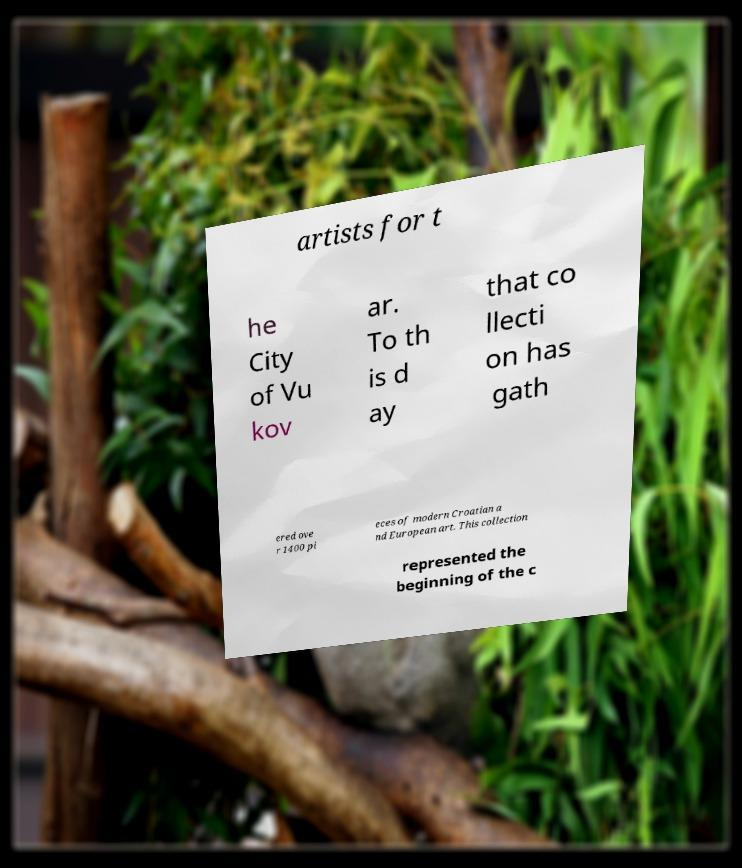Could you extract and type out the text from this image? artists for t he City of Vu kov ar. To th is d ay that co llecti on has gath ered ove r 1400 pi eces of modern Croatian a nd European art. This collection represented the beginning of the c 